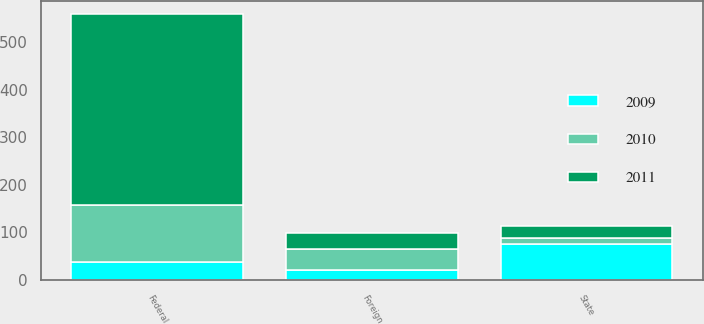Convert chart to OTSL. <chart><loc_0><loc_0><loc_500><loc_500><stacked_bar_chart><ecel><fcel>Federal<fcel>State<fcel>Foreign<nl><fcel>2010<fcel>119<fcel>12<fcel>44<nl><fcel>2011<fcel>401<fcel>26<fcel>33<nl><fcel>2009<fcel>38.5<fcel>75<fcel>21<nl></chart> 